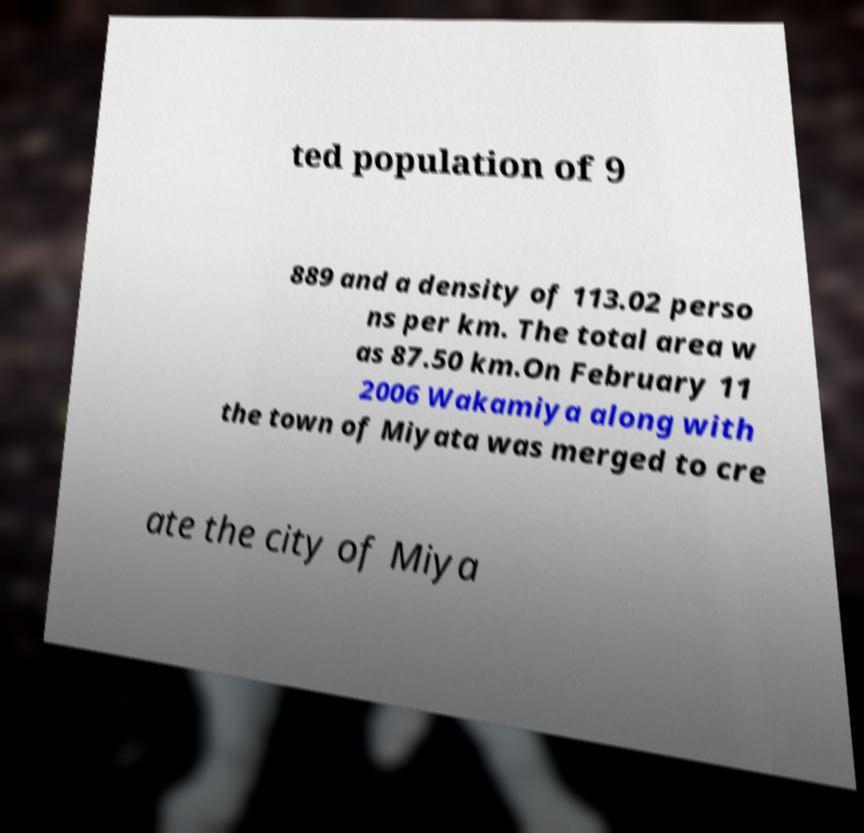For documentation purposes, I need the text within this image transcribed. Could you provide that? ted population of 9 889 and a density of 113.02 perso ns per km. The total area w as 87.50 km.On February 11 2006 Wakamiya along with the town of Miyata was merged to cre ate the city of Miya 